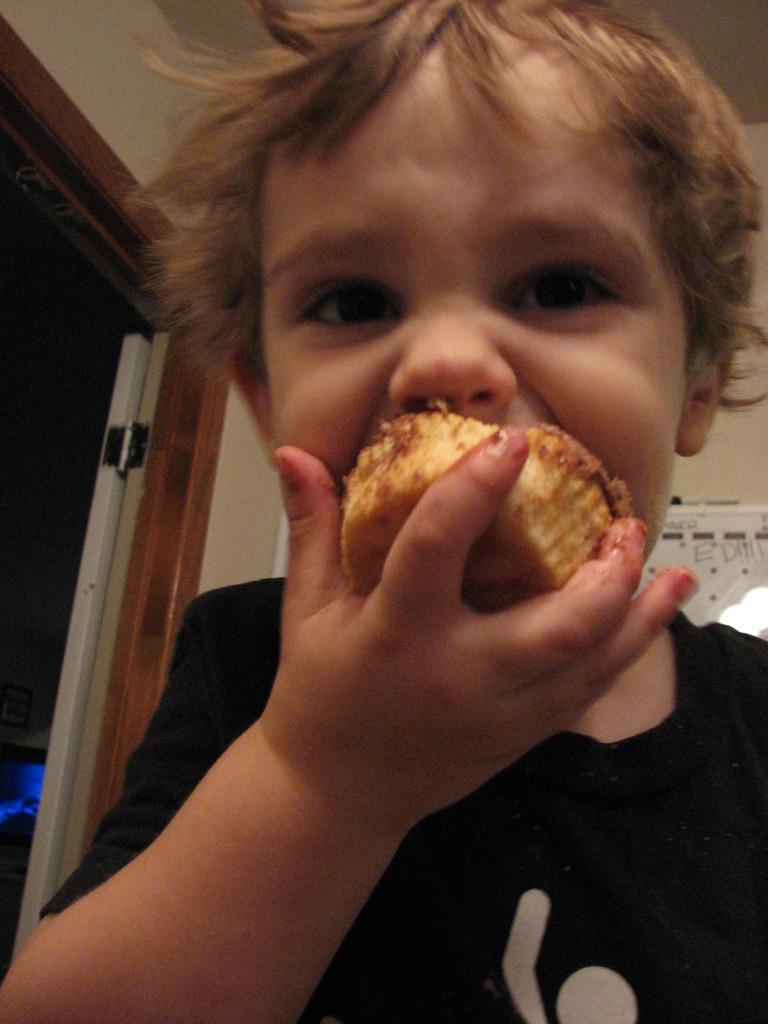Please provide a concise description of this image. In this image in front there is a boy eating cupcake. Behind him there is a wall with the poster on it. On the left side of the image there is a door. 